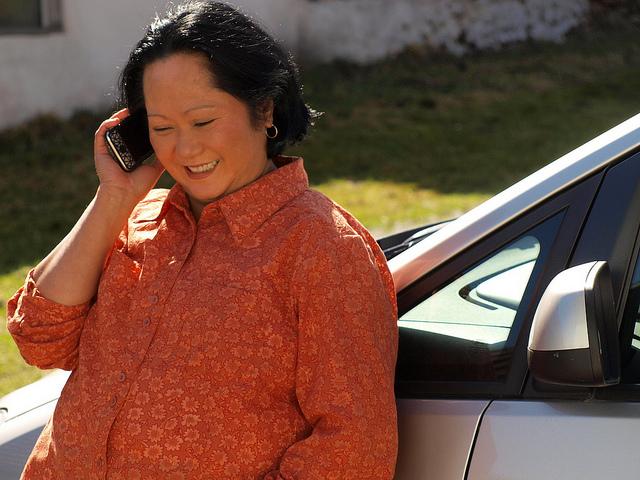Is she wearing earrings?
Write a very short answer. Yes. What color is the woman's hair?
Write a very short answer. Black. Is the woman smiling?
Concise answer only. Yes. What is the pattern of the person's shirt?
Quick response, please. Floral. What is in front of the lady?
Answer briefly. Car. Is the photographer looking out the window?
Give a very brief answer. No. Is the woman listening to good news?
Be succinct. Yes. What is this person have on her hand?
Answer briefly. Cell phone. Is the woman holding a cell phone?
Concise answer only. Yes. 